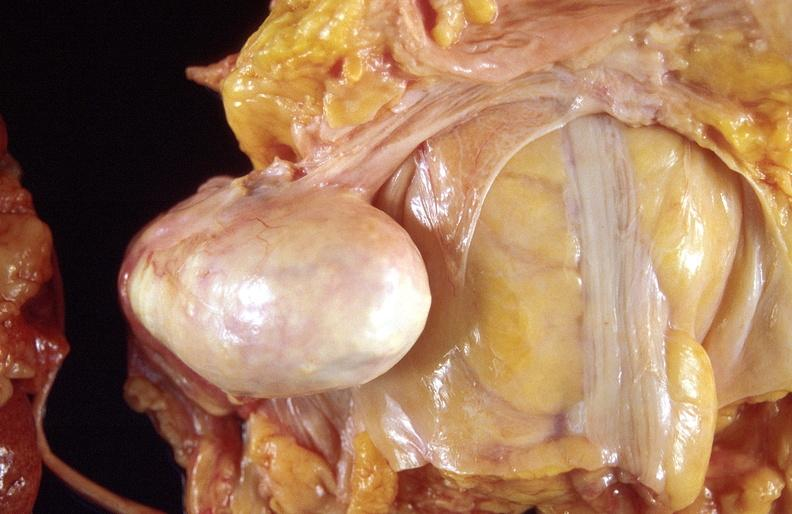does metastatic carcinoma prostate show dermoid cyst?
Answer the question using a single word or phrase. No 